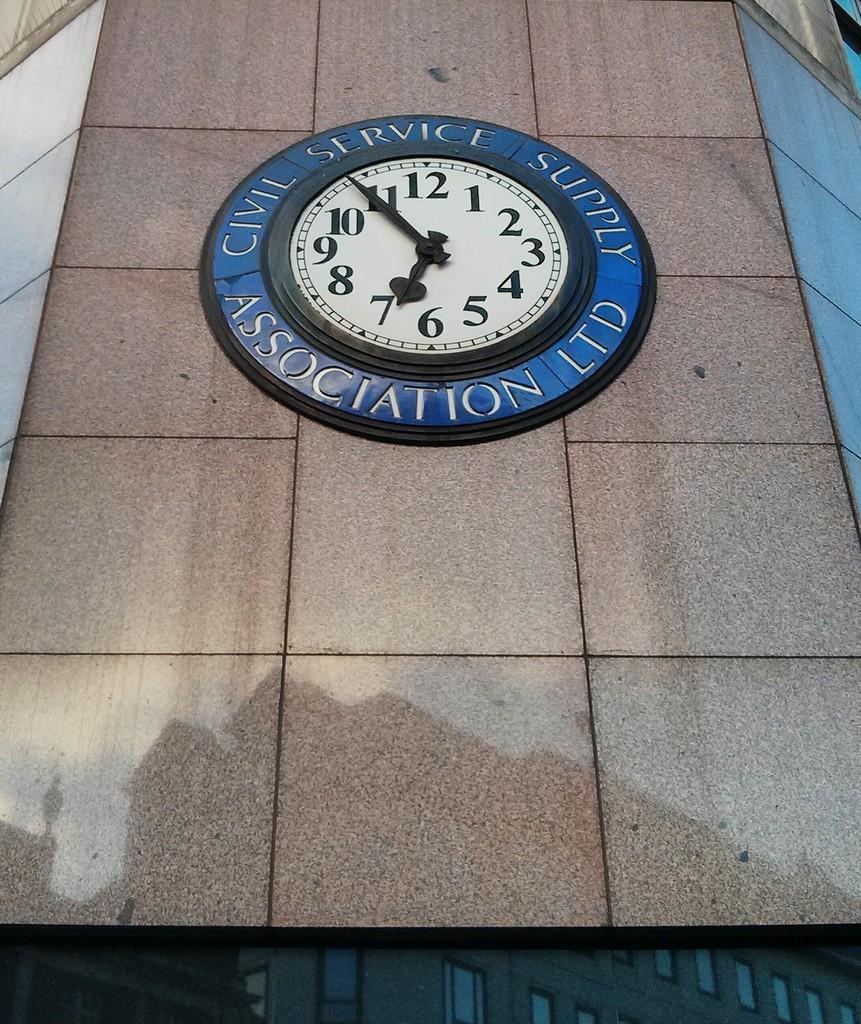Please provide a concise description of this image. In this image I can see a clock attached to the building. The building is in brown color. 